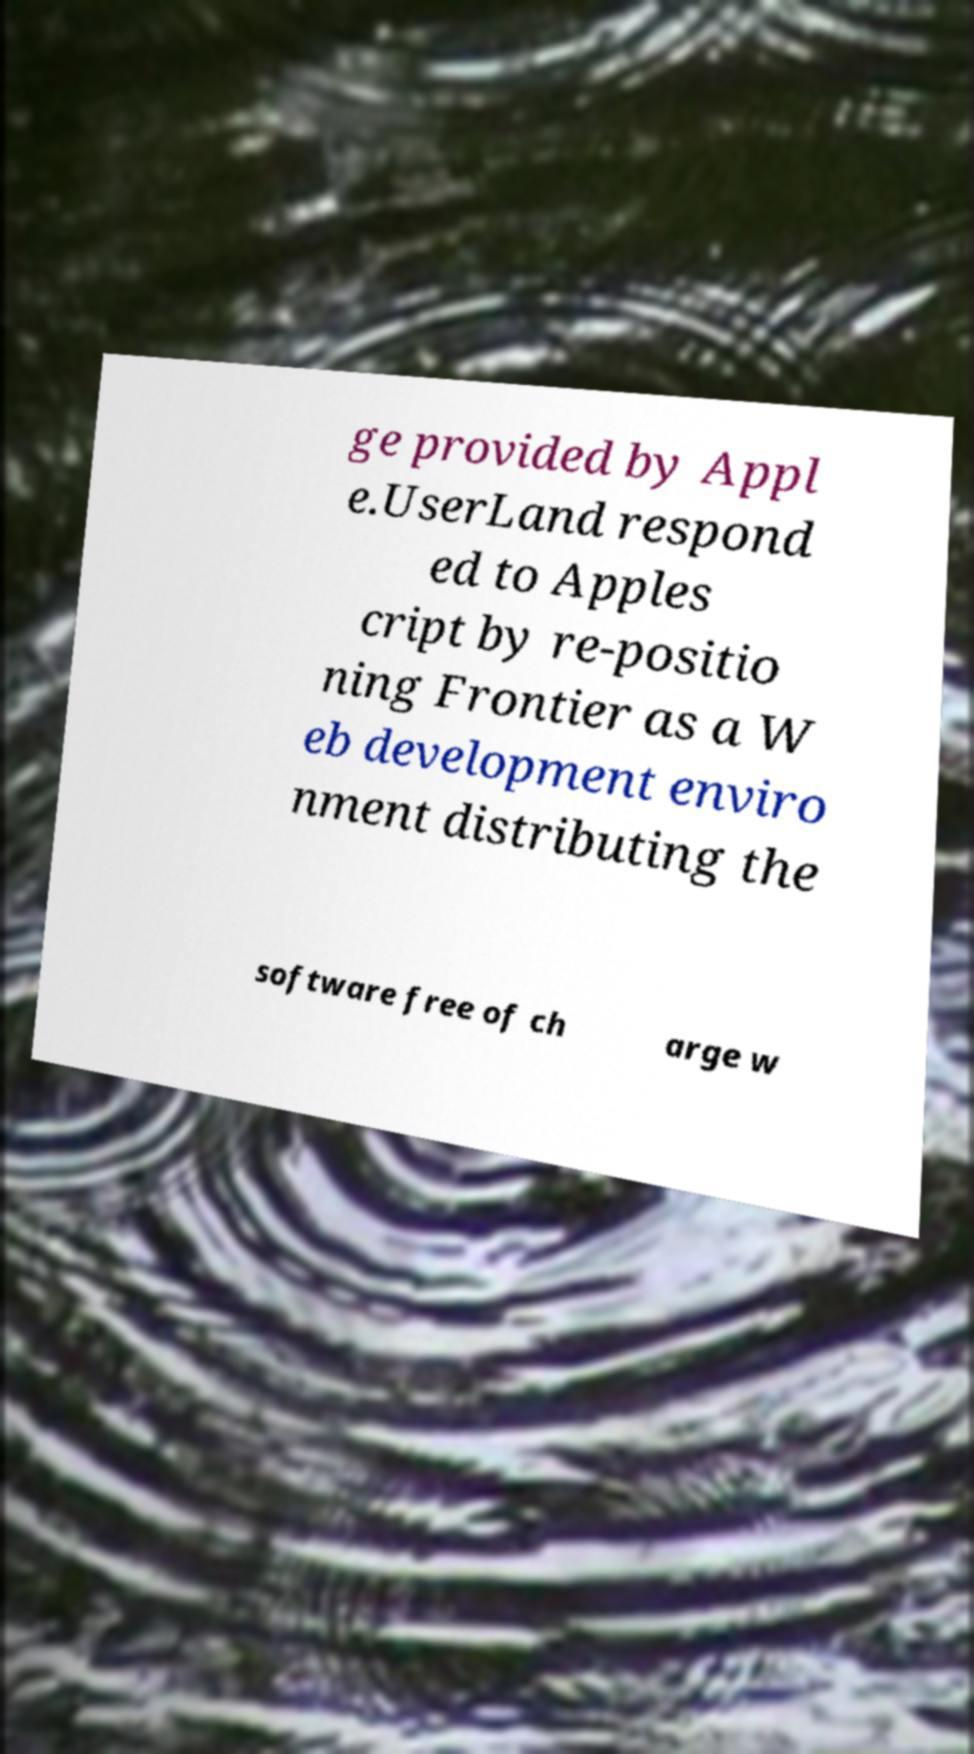Could you extract and type out the text from this image? ge provided by Appl e.UserLand respond ed to Apples cript by re-positio ning Frontier as a W eb development enviro nment distributing the software free of ch arge w 